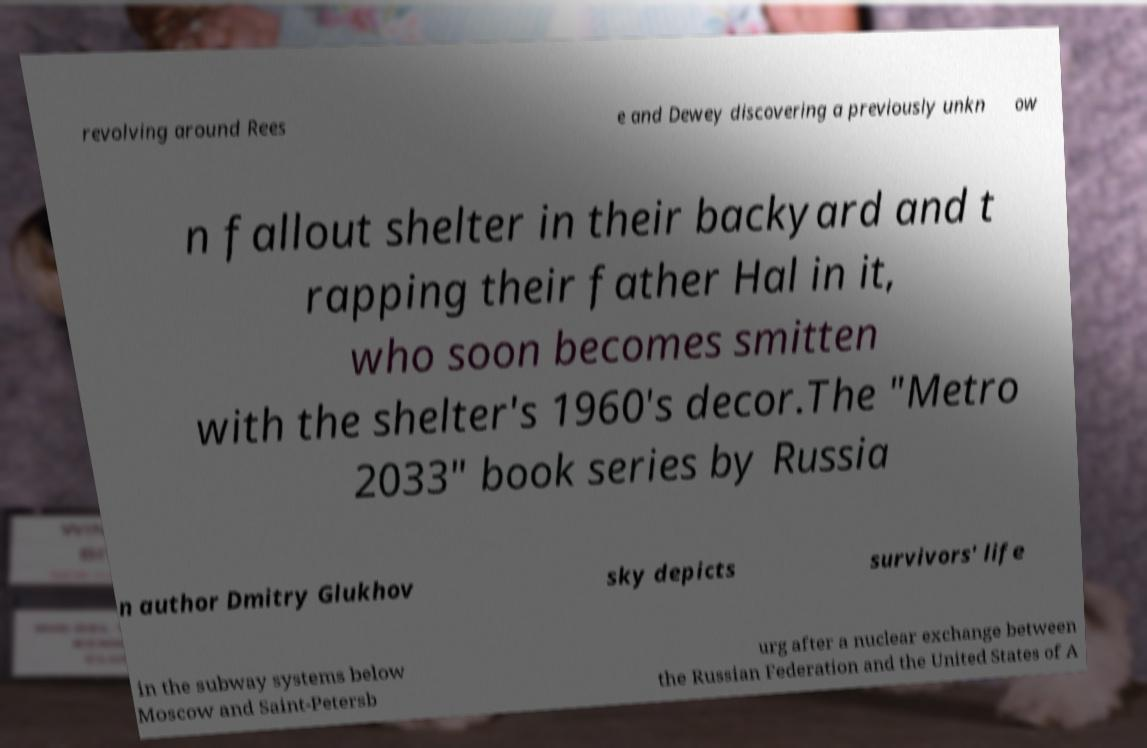What messages or text are displayed in this image? I need them in a readable, typed format. revolving around Rees e and Dewey discovering a previously unkn ow n fallout shelter in their backyard and t rapping their father Hal in it, who soon becomes smitten with the shelter's 1960's decor.The "Metro 2033" book series by Russia n author Dmitry Glukhov sky depicts survivors' life in the subway systems below Moscow and Saint-Petersb urg after a nuclear exchange between the Russian Federation and the United States of A 